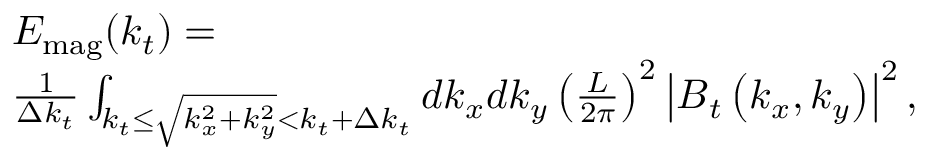<formula> <loc_0><loc_0><loc_500><loc_500>\begin{array} { r l } & { E _ { m a g } ( k _ { t } ) = } \\ & { \frac { 1 } { \Delta k _ { t } } \int _ { k _ { t } \leq \sqrt { k _ { x } ^ { 2 } + k _ { y } ^ { 2 } } < k _ { t } + \Delta k _ { t } } d k _ { x } d k _ { y } \left ( \frac { L } { 2 \pi } \right ) ^ { 2 } \left | B _ { t } \left ( k _ { x } , k _ { y } \right ) \right | ^ { 2 } , } \end{array}</formula> 